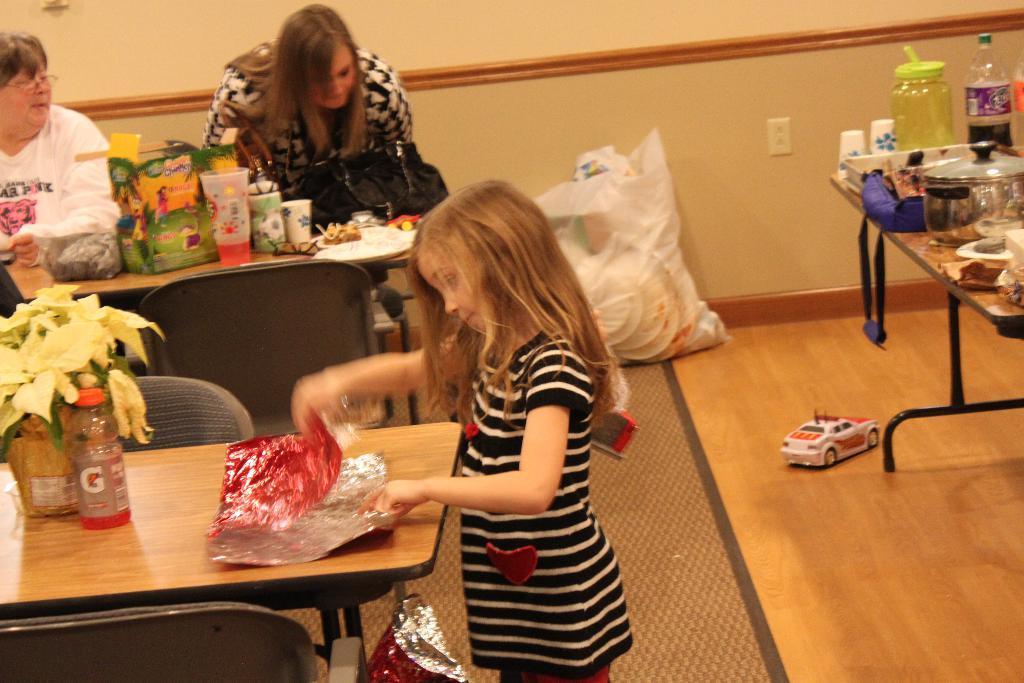How would you summarize this image in a sentence or two? In this picture we can see three persons were two woman and one girl is holding color paper in her hands and on table we can see bottle, vase with flowers, covers, glasses and beside to them there is toy car, vessels, jar, bag, wall. 